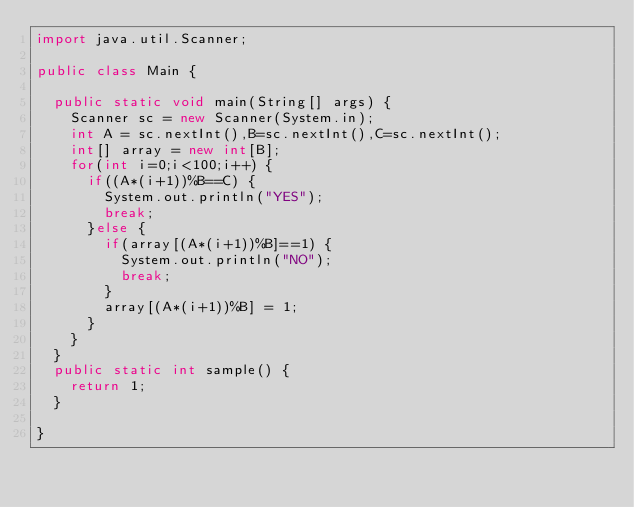<code> <loc_0><loc_0><loc_500><loc_500><_Java_>import java.util.Scanner;

public class Main {

	public static void main(String[] args) {
		Scanner sc = new Scanner(System.in);
		int	A = sc.nextInt(),B=sc.nextInt(),C=sc.nextInt();
		int[] array = new int[B];
		for(int i=0;i<100;i++) {
			if((A*(i+1))%B==C) {
				System.out.println("YES");
				break;
			}else {
				if(array[(A*(i+1))%B]==1) {
					System.out.println("NO");
					break;
				}
				array[(A*(i+1))%B] = 1;
			}
		}
	}
	public static int sample() {
		return 1;
	}

}
</code> 